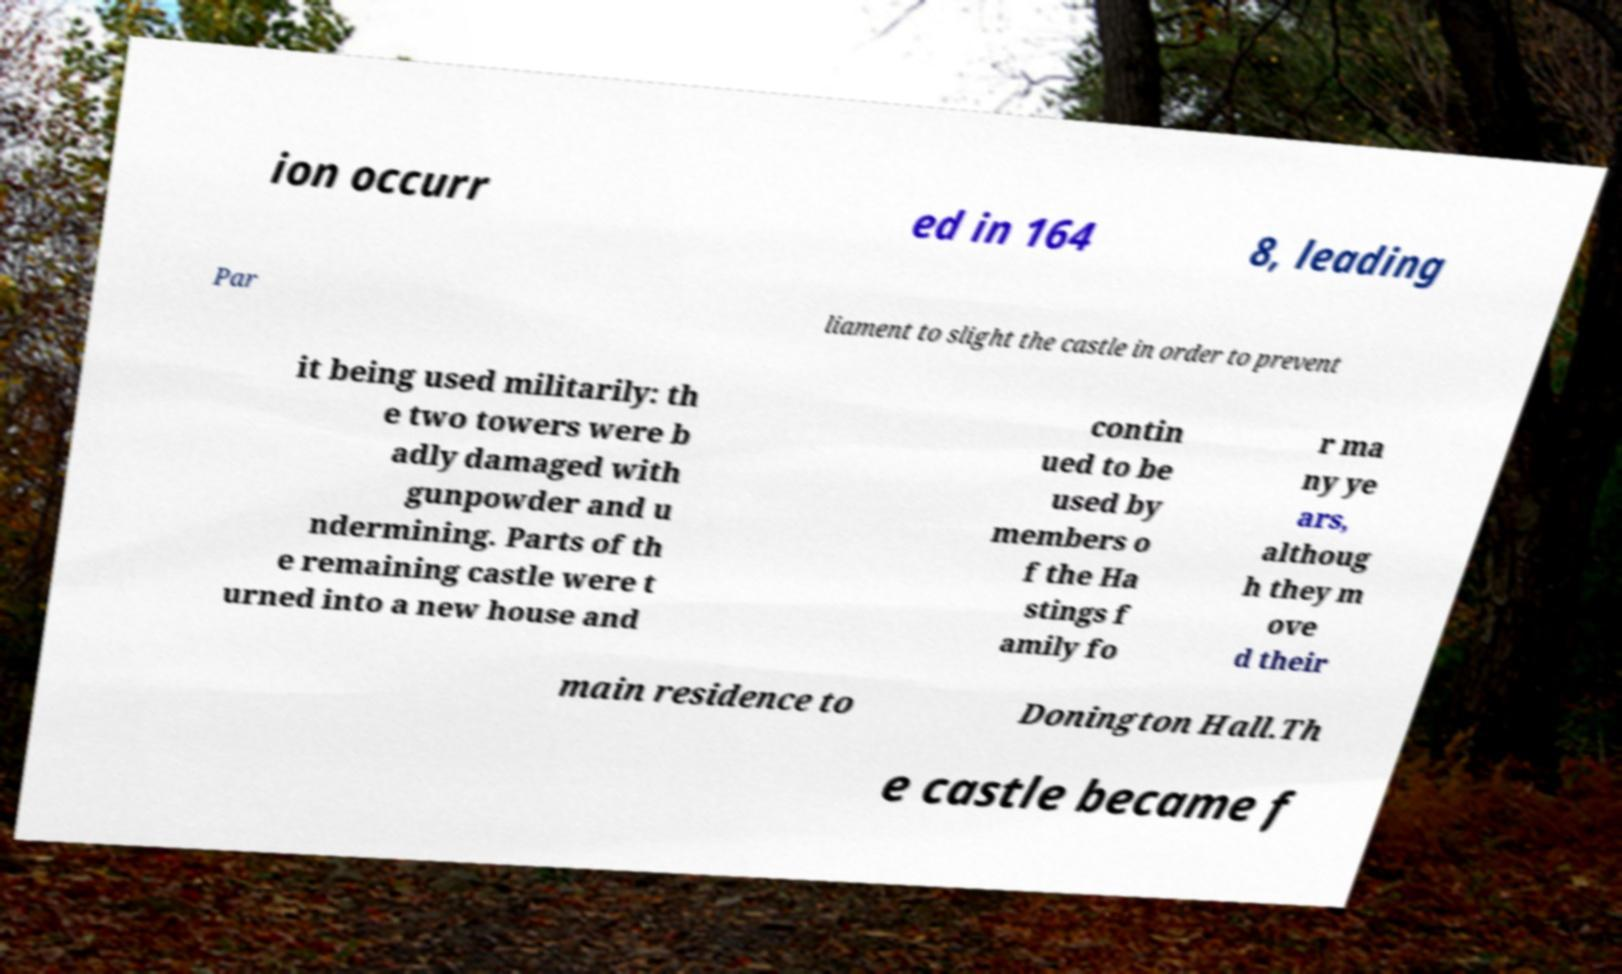Please identify and transcribe the text found in this image. ion occurr ed in 164 8, leading Par liament to slight the castle in order to prevent it being used militarily: th e two towers were b adly damaged with gunpowder and u ndermining. Parts of th e remaining castle were t urned into a new house and contin ued to be used by members o f the Ha stings f amily fo r ma ny ye ars, althoug h they m ove d their main residence to Donington Hall.Th e castle became f 